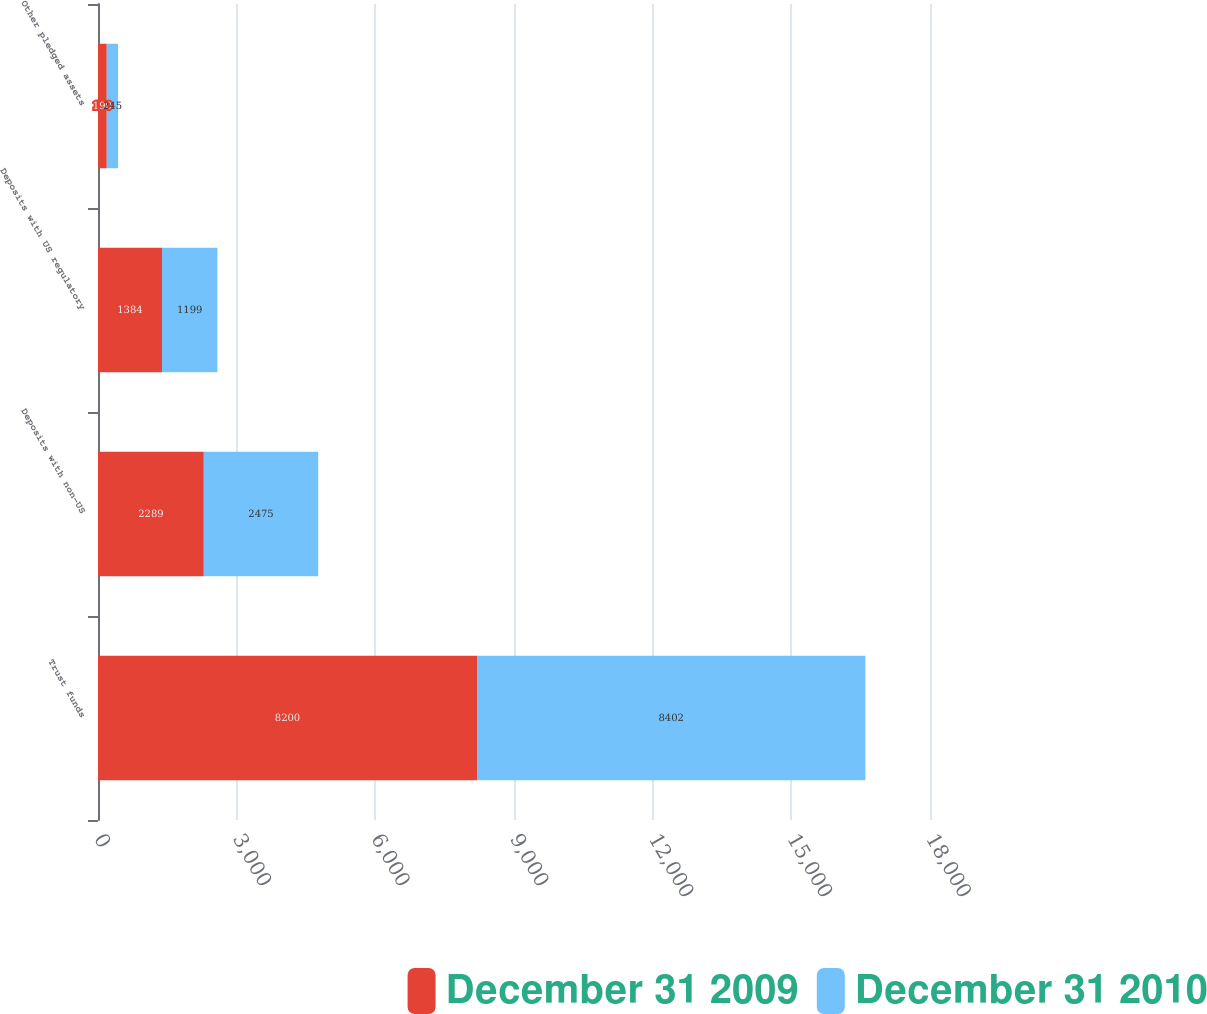<chart> <loc_0><loc_0><loc_500><loc_500><stacked_bar_chart><ecel><fcel>Trust funds<fcel>Deposits with non-US<fcel>Deposits with US regulatory<fcel>Other pledged assets<nl><fcel>December 31 2009<fcel>8200<fcel>2289<fcel>1384<fcel>190<nl><fcel>December 31 2010<fcel>8402<fcel>2475<fcel>1199<fcel>245<nl></chart> 